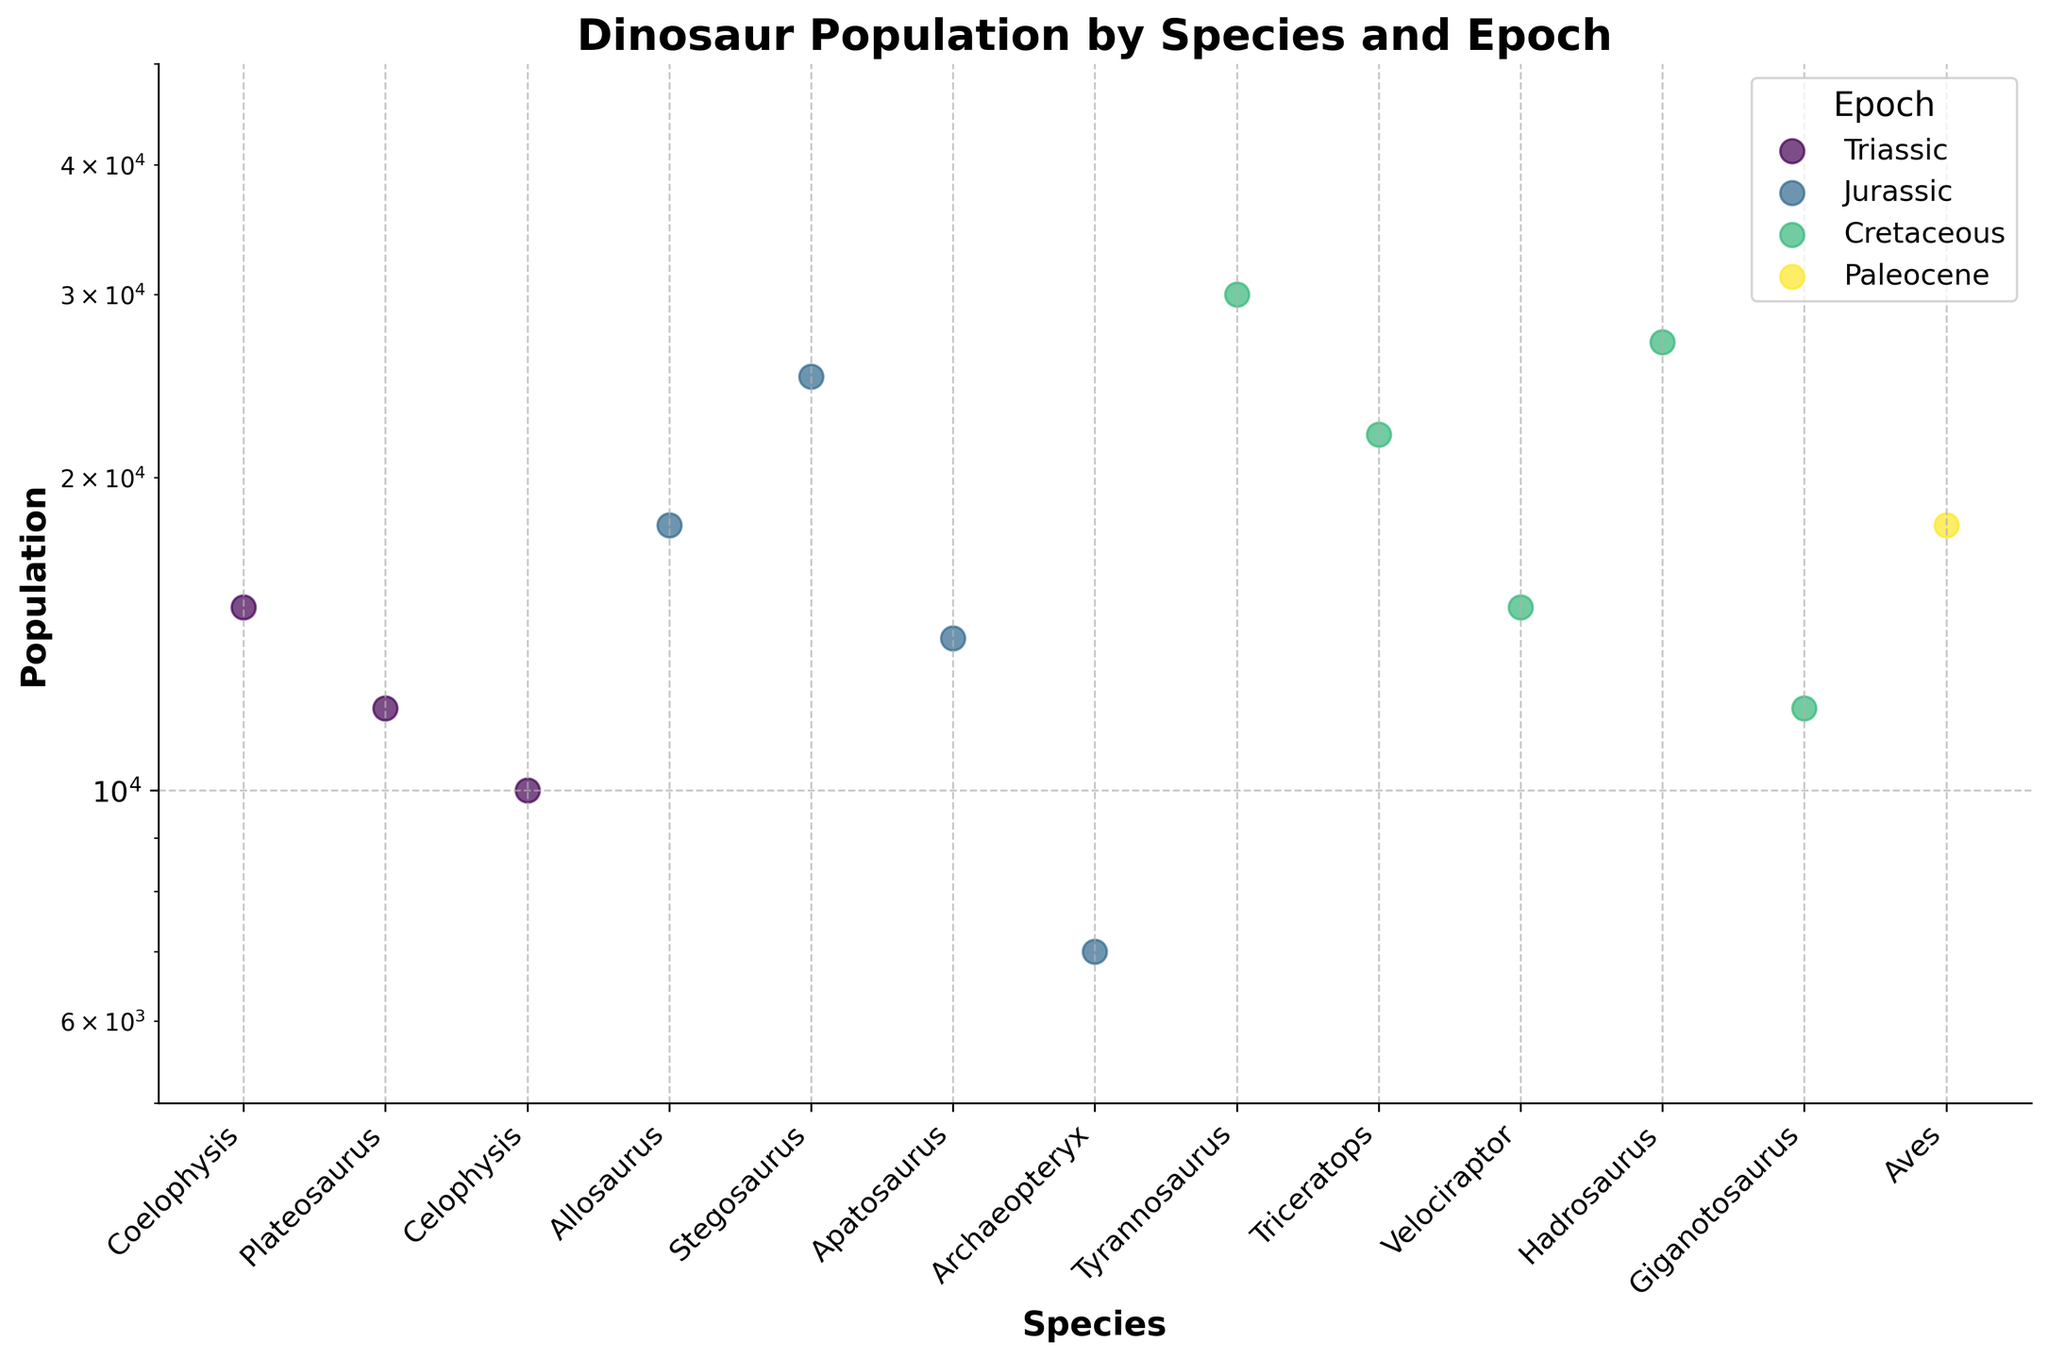What's the title of the figure? The title of a figure is usually displayed at the top. The figure here has a bold title text displayed prominently.
Answer: Dinosaur Population by Species and Epoch How does the population of Coelophysis in the Triassic compare to the population of Aves in the Paleocene? Looking at the scatter plot, we can see the population for Coelophysis and Aves. Coelophysis has a population of 15,000 while Aves has a population of 18,000. Therefore, the population of Aves is higher.
Answer: Aves has a higher population Which species in the Cretaceous epoch has the highest population in the diagram? Observing the Cretaceous epoch data points, we see that Tyrannosaurus, Triceratops, Velociraptor, Hadrosaurus, and Giganotosaurus are plotted. The population values are compared visually, and Tyrannosaurus, with a population of 30,000, is the highest.
Answer: Tyrannosaurus How many species are documented in the Jurassic epoch according to the figure? By counting the number of species data points specific to the Jurassic epoch in the scatter plot, we can see the total. The species listed are Allosaurus, Stegosaurus, Apatosaurus, and Archaeopteryx, making a total of four.
Answer: 4 species Which epoch has more species documented: Triassic or Jurassic? Counting the number of data points for each epoch in the scatter plot helps us compare. The Triassic has three species (Coelophysis, Plateosaurus, Celophysis), while the Jurassic has four (Allosaurus, Stegosaurus, Apatosaurus, Archaeopteryx). Therefore, the Jurassic epoch has more species documented.
Answer: Jurassic What is the population range (difference between the maximum and minimum population) in the Cretaceous epoch? Checking the data points for the Cretaceous epoch, the populations are: Tyrannosaurus (30,000), Triceratops (22,000), Velociraptor (15,000), Hadrosaurus (27,000), Giganotosaurus (12,000). The maximum population is 30,000, and the minimum is 12,000; the difference is 30,000 - 12,000.
Answer: 18,000 Which epoch shows the most significant variation in population among its species? To determine the epoch with the most significant variation in population, we visually compare the population values of each species within an epoch. The Cretaceous, with a population range from 12,000 to 30,000, appears to show the highest spread or variation in population values.
Answer: Cretaceous What is the median population of species in the Jurassic epoch? By listing the populations of Jurassic species (7,000 for Archaeopteryx, 14,000 for Apatosaurus, 18,000 for Allosaurus, and 25,000 for Stegosaurus) and arranging them in order, the median (middle value) can be determined. The ordered values are 7,000, 14,000, 18,000, and 25,000. The median is the average of 14,000 and 18,000.
Answer: 16,000 